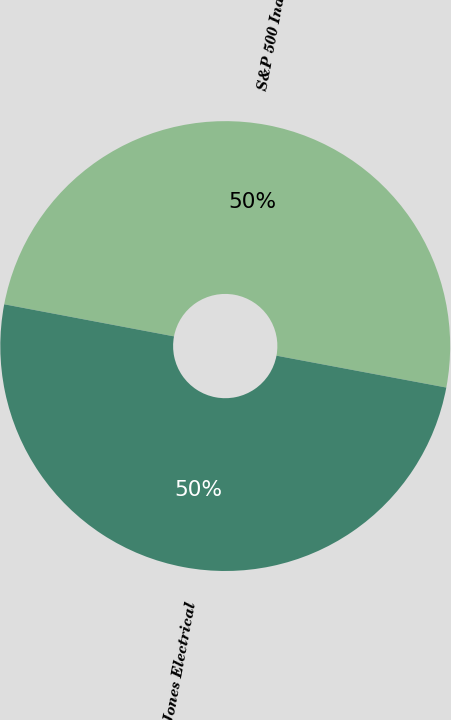<chart> <loc_0><loc_0><loc_500><loc_500><pie_chart><fcel>S&P 500 Index<fcel>Dow Jones Electrical<nl><fcel>49.98%<fcel>50.02%<nl></chart> 